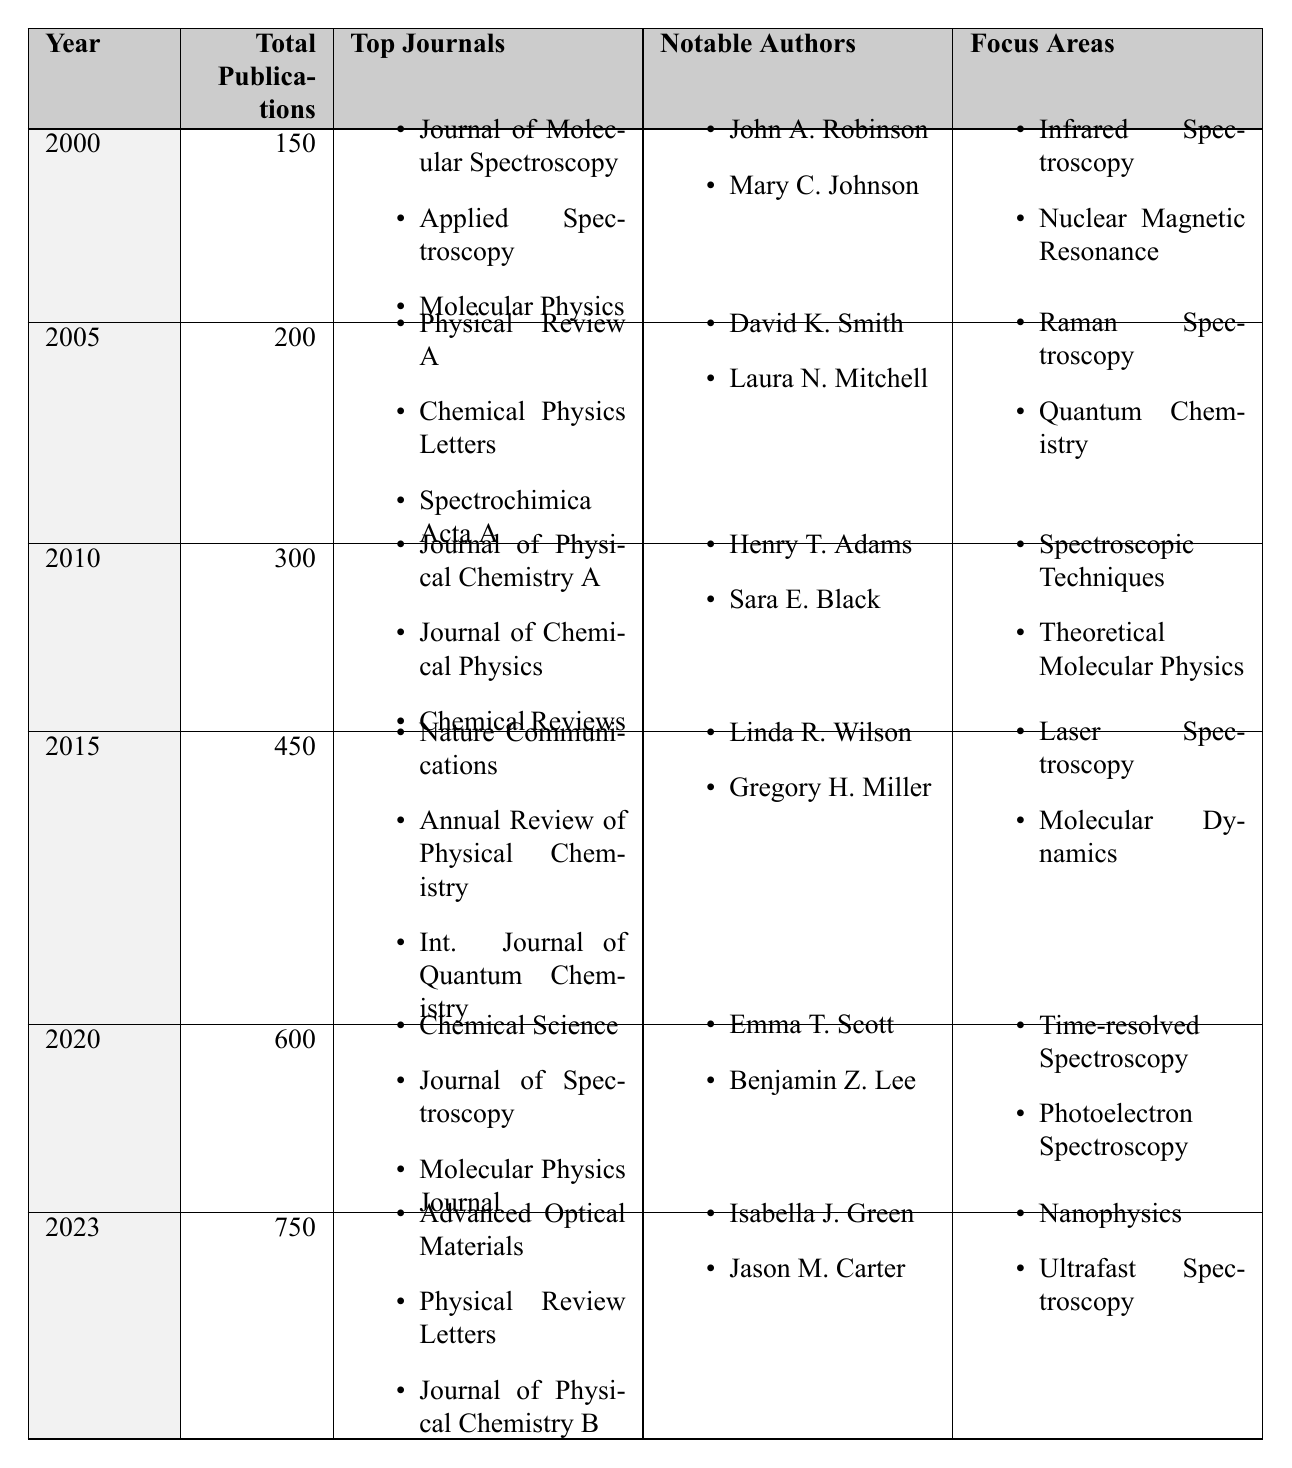What was the total number of publications in 2010? In the row for the year 2010 in the table, the total number of publications is explicitly stated as 300.
Answer: 300 Which year had the highest total publications? The highest total publications can be found by comparing the 'Total Publications' column across all years. In 2023, the total is 750, which is greater than any other year.
Answer: 2023 How many journals were listed for the year 2005? The year 2005 has a specific list of journals that includes three entries. This can be counted directly from the table.
Answer: 3 What was the increase in total publications from 2000 to 2020? The total publications in 2000 are 150, while in 2020 they are 600. The increase can be calculated as 600 - 150 = 450.
Answer: 450 Did any notable authors in 2015 contribute to the field of Laser Spectroscopy? The notable authors listed for 2015 include Linda R. Wilson and Gregory H. Miller. The focus area for that year includes Laser Spectroscopy, indicating a contribution to that field.
Answer: Yes What is the average number of publications from 2000 to 2020? The total publications over those years are: 150 (2000) + 200 (2005) + 300 (2010) + 450 (2015) + 600 (2020) = 1700. There are 5 data points, so the average is 1700 / 5 = 340.
Answer: 340 Which focus area was common in both 2000 and 2010? The focus areas for 2000 include Infrared Spectroscopy and Nuclear Magnetic Resonance, while for 2010, they include Spectroscopic Techniques and Theoretical Molecular Physics. There are no common focus areas.
Answer: None In which year did the notable author Emma T. Scott publish? The notable author Emma T. Scott is listed for the year 2020. This can be found directly in the corresponding row of the table.
Answer: 2020 How many notable authors were there in total from 2000 to 2023? Counting the notable authors from each year: 2 (2000) + 2 (2005) + 2 (2010) + 2 (2015) + 2 (2020) + 2 (2023) gives a total of 12 notable authors across all years.
Answer: 12 Was Quantum Chemistry a focus area in 2010? Quantum Chemistry is listed under the focus areas for the year 2005 but not for 2010. The focus areas for 2010 include Spectroscopic Techniques and Theoretical Molecular Physics.
Answer: No Which journals were prominent in the year 2023? The top journals for 2023 include Advanced Optical Materials, Physical Review Letters, and Journal of Physical Chemistry B. These can be directly found in the respective row for that year.
Answer: Advanced Optical Materials, Physical Review Letters, Journal of Physical Chemistry B 